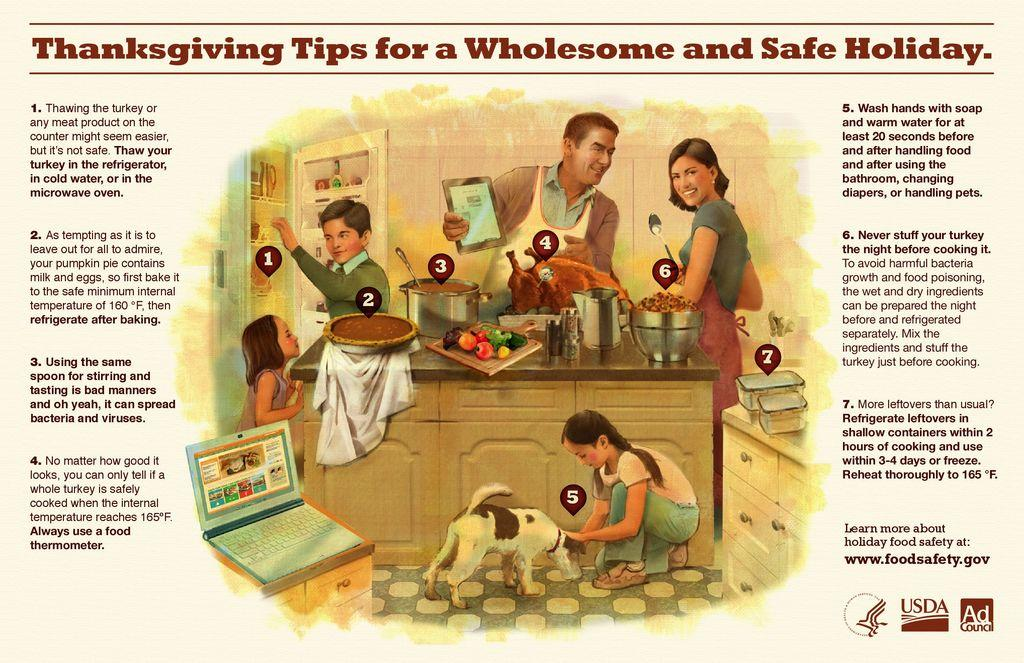Provide a one-sentence caption for the provided image. The poster shows a family preparing for a wholesome Thanksgiving dinner. 